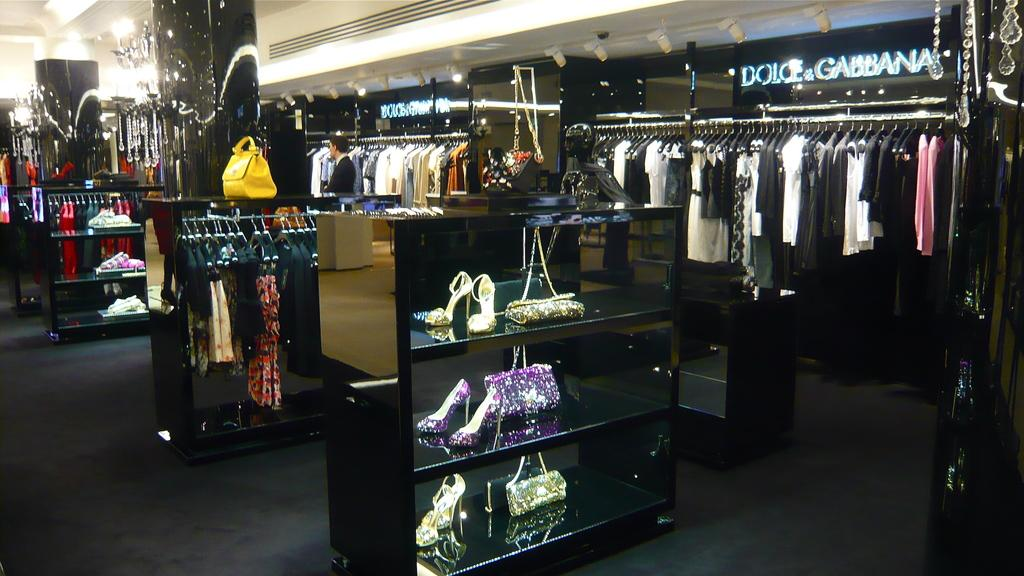<image>
Describe the image concisely. Dolce and Gabbana boutique store inside a mall. 